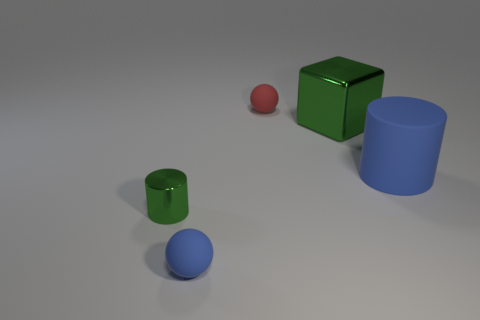Is the large shiny thing the same color as the tiny metallic cylinder?
Give a very brief answer. Yes. Is there any other thing that has the same material as the large block?
Provide a succinct answer. Yes. Are there any green cubes that are in front of the big blue matte thing that is on the right side of the block?
Offer a very short reply. No. What number of big objects are either green cubes or red matte balls?
Provide a succinct answer. 1. Are there any yellow objects that have the same size as the red matte thing?
Provide a short and direct response. No. How many matte objects are tiny green cylinders or objects?
Ensure brevity in your answer.  3. What shape is the other metal thing that is the same color as the big metallic object?
Provide a succinct answer. Cylinder. How many large metal objects are there?
Your response must be concise. 1. Are the green thing that is left of the red rubber sphere and the blue object that is on the left side of the blue rubber cylinder made of the same material?
Your answer should be compact. No. There is a blue cylinder that is the same material as the blue ball; what size is it?
Give a very brief answer. Large. 